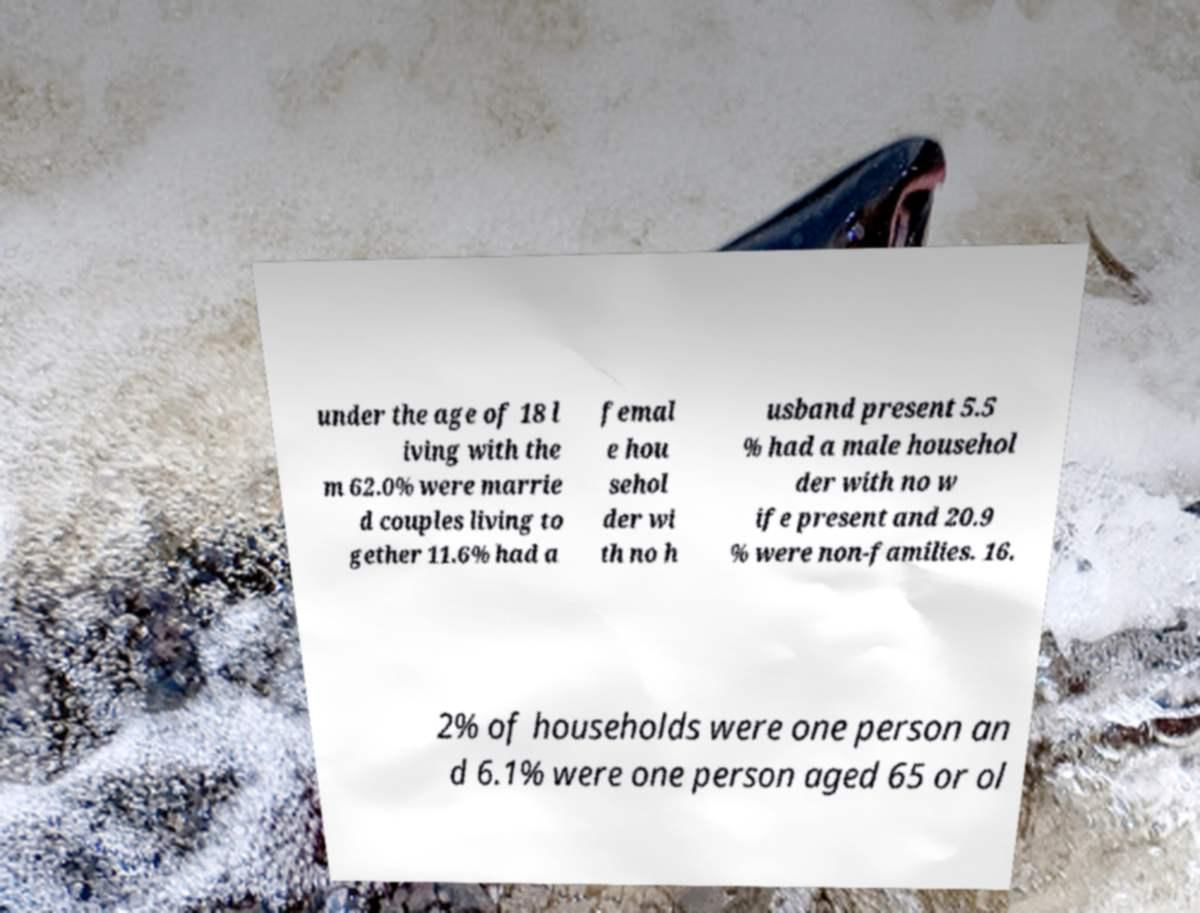Could you assist in decoding the text presented in this image and type it out clearly? under the age of 18 l iving with the m 62.0% were marrie d couples living to gether 11.6% had a femal e hou sehol der wi th no h usband present 5.5 % had a male househol der with no w ife present and 20.9 % were non-families. 16. 2% of households were one person an d 6.1% were one person aged 65 or ol 